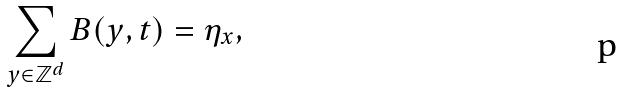Convert formula to latex. <formula><loc_0><loc_0><loc_500><loc_500>\sum _ { y \in \mathbb { Z } ^ { d } } B ( y , t ) = \eta _ { x } ,</formula> 